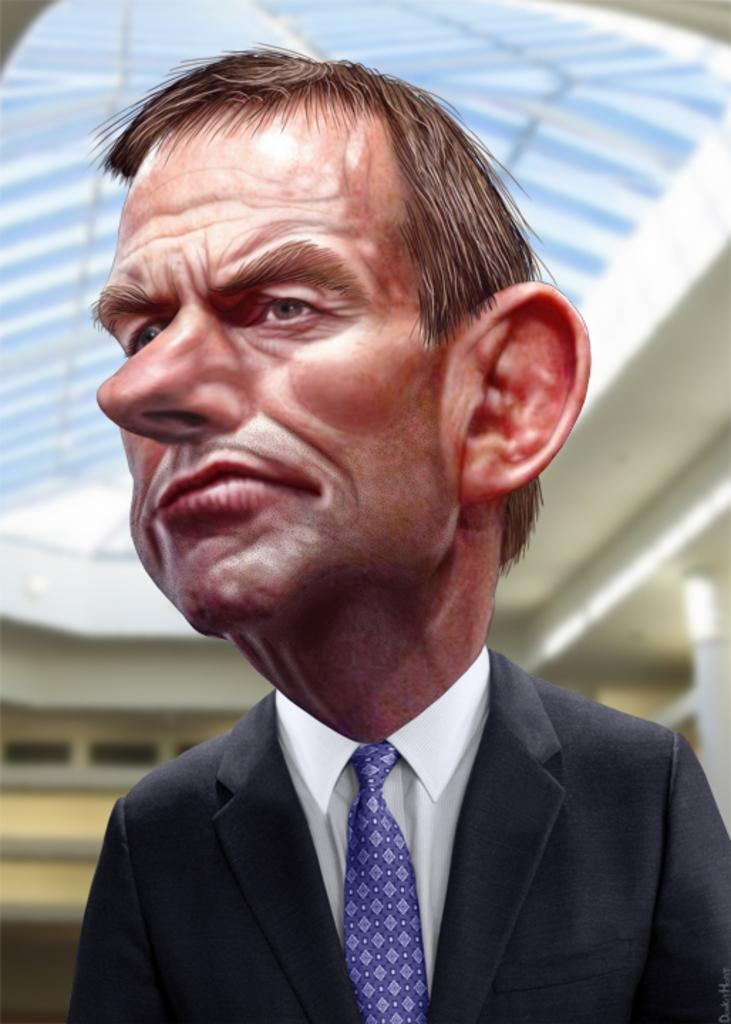What is the main subject of the image? There is a depiction of a person in the image. What can be seen in the background of the image? There is a building behind the person in the image. Is there any text present in the image? Yes, there is some text at the bottom of the image. Can you tell me how much rice the person is holding in the image? There is no rice present in the image, and the person is not holding anything. 